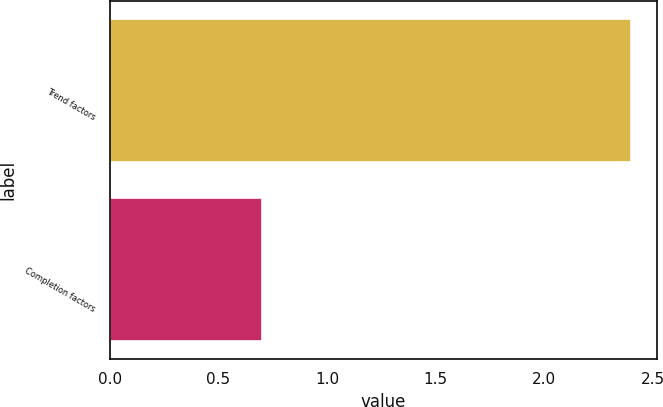Convert chart to OTSL. <chart><loc_0><loc_0><loc_500><loc_500><bar_chart><fcel>Trend factors<fcel>Completion factors<nl><fcel>2.4<fcel>0.7<nl></chart> 